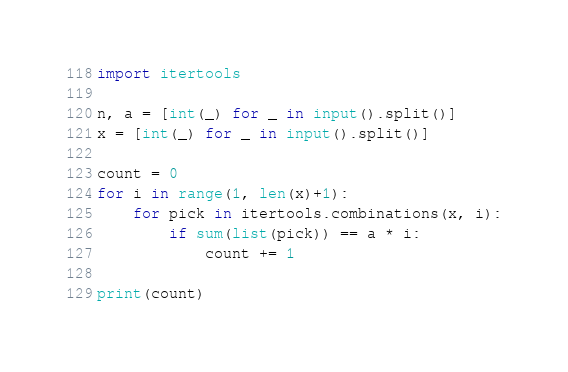<code> <loc_0><loc_0><loc_500><loc_500><_Python_>import itertools

n, a = [int(_) for _ in input().split()]
x = [int(_) for _ in input().split()]

count = 0
for i in range(1, len(x)+1):
    for pick in itertools.combinations(x, i):
        if sum(list(pick)) == a * i:
            count += 1

print(count)
</code> 